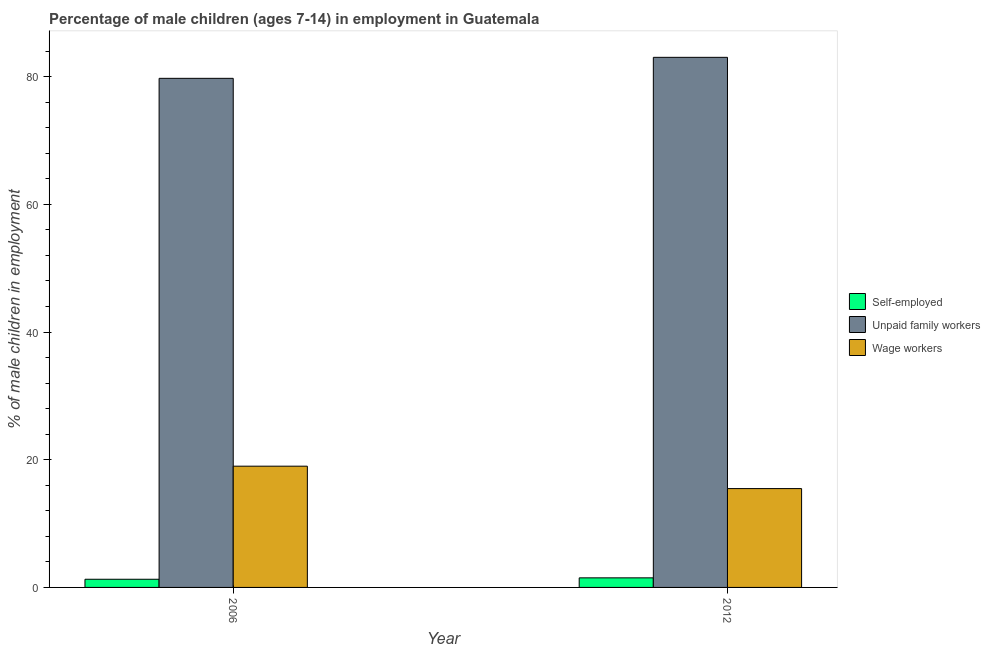How many groups of bars are there?
Ensure brevity in your answer.  2. Are the number of bars per tick equal to the number of legend labels?
Your answer should be very brief. Yes. Are the number of bars on each tick of the X-axis equal?
Offer a very short reply. Yes. What is the label of the 2nd group of bars from the left?
Ensure brevity in your answer.  2012. In how many cases, is the number of bars for a given year not equal to the number of legend labels?
Provide a short and direct response. 0. What is the percentage of children employed as unpaid family workers in 2006?
Provide a short and direct response. 79.73. Across all years, what is the maximum percentage of children employed as unpaid family workers?
Give a very brief answer. 83.02. Across all years, what is the minimum percentage of children employed as wage workers?
Your answer should be very brief. 15.48. In which year was the percentage of self employed children maximum?
Keep it short and to the point. 2012. In which year was the percentage of children employed as wage workers minimum?
Provide a succinct answer. 2012. What is the total percentage of children employed as wage workers in the graph?
Offer a terse response. 34.47. What is the difference between the percentage of children employed as wage workers in 2006 and that in 2012?
Provide a succinct answer. 3.51. What is the difference between the percentage of children employed as wage workers in 2006 and the percentage of self employed children in 2012?
Your answer should be very brief. 3.51. What is the average percentage of children employed as unpaid family workers per year?
Your response must be concise. 81.38. What is the ratio of the percentage of children employed as wage workers in 2006 to that in 2012?
Provide a succinct answer. 1.23. Is the percentage of children employed as unpaid family workers in 2006 less than that in 2012?
Make the answer very short. Yes. What does the 3rd bar from the left in 2012 represents?
Your response must be concise. Wage workers. What does the 1st bar from the right in 2006 represents?
Your answer should be compact. Wage workers. Is it the case that in every year, the sum of the percentage of self employed children and percentage of children employed as unpaid family workers is greater than the percentage of children employed as wage workers?
Your answer should be compact. Yes. How many bars are there?
Your answer should be compact. 6. What is the difference between two consecutive major ticks on the Y-axis?
Your answer should be compact. 20. Does the graph contain any zero values?
Give a very brief answer. No. Where does the legend appear in the graph?
Your answer should be very brief. Center right. How many legend labels are there?
Make the answer very short. 3. How are the legend labels stacked?
Ensure brevity in your answer.  Vertical. What is the title of the graph?
Offer a terse response. Percentage of male children (ages 7-14) in employment in Guatemala. Does "Services" appear as one of the legend labels in the graph?
Your answer should be compact. No. What is the label or title of the X-axis?
Give a very brief answer. Year. What is the label or title of the Y-axis?
Ensure brevity in your answer.  % of male children in employment. What is the % of male children in employment of Self-employed in 2006?
Ensure brevity in your answer.  1.28. What is the % of male children in employment in Unpaid family workers in 2006?
Provide a short and direct response. 79.73. What is the % of male children in employment in Wage workers in 2006?
Your answer should be compact. 18.99. What is the % of male children in employment of Self-employed in 2012?
Keep it short and to the point. 1.5. What is the % of male children in employment in Unpaid family workers in 2012?
Your response must be concise. 83.02. What is the % of male children in employment in Wage workers in 2012?
Make the answer very short. 15.48. Across all years, what is the maximum % of male children in employment in Self-employed?
Keep it short and to the point. 1.5. Across all years, what is the maximum % of male children in employment of Unpaid family workers?
Provide a succinct answer. 83.02. Across all years, what is the maximum % of male children in employment in Wage workers?
Offer a terse response. 18.99. Across all years, what is the minimum % of male children in employment in Self-employed?
Offer a terse response. 1.28. Across all years, what is the minimum % of male children in employment of Unpaid family workers?
Provide a short and direct response. 79.73. Across all years, what is the minimum % of male children in employment of Wage workers?
Give a very brief answer. 15.48. What is the total % of male children in employment in Self-employed in the graph?
Your response must be concise. 2.78. What is the total % of male children in employment of Unpaid family workers in the graph?
Ensure brevity in your answer.  162.75. What is the total % of male children in employment of Wage workers in the graph?
Your answer should be compact. 34.47. What is the difference between the % of male children in employment of Self-employed in 2006 and that in 2012?
Give a very brief answer. -0.22. What is the difference between the % of male children in employment of Unpaid family workers in 2006 and that in 2012?
Keep it short and to the point. -3.29. What is the difference between the % of male children in employment in Wage workers in 2006 and that in 2012?
Keep it short and to the point. 3.51. What is the difference between the % of male children in employment of Self-employed in 2006 and the % of male children in employment of Unpaid family workers in 2012?
Provide a short and direct response. -81.74. What is the difference between the % of male children in employment of Self-employed in 2006 and the % of male children in employment of Wage workers in 2012?
Your answer should be very brief. -14.2. What is the difference between the % of male children in employment of Unpaid family workers in 2006 and the % of male children in employment of Wage workers in 2012?
Ensure brevity in your answer.  64.25. What is the average % of male children in employment of Self-employed per year?
Provide a succinct answer. 1.39. What is the average % of male children in employment in Unpaid family workers per year?
Ensure brevity in your answer.  81.38. What is the average % of male children in employment in Wage workers per year?
Offer a very short reply. 17.23. In the year 2006, what is the difference between the % of male children in employment of Self-employed and % of male children in employment of Unpaid family workers?
Your answer should be compact. -78.45. In the year 2006, what is the difference between the % of male children in employment of Self-employed and % of male children in employment of Wage workers?
Your response must be concise. -17.71. In the year 2006, what is the difference between the % of male children in employment in Unpaid family workers and % of male children in employment in Wage workers?
Offer a terse response. 60.74. In the year 2012, what is the difference between the % of male children in employment of Self-employed and % of male children in employment of Unpaid family workers?
Provide a short and direct response. -81.52. In the year 2012, what is the difference between the % of male children in employment in Self-employed and % of male children in employment in Wage workers?
Keep it short and to the point. -13.98. In the year 2012, what is the difference between the % of male children in employment in Unpaid family workers and % of male children in employment in Wage workers?
Offer a terse response. 67.54. What is the ratio of the % of male children in employment of Self-employed in 2006 to that in 2012?
Your answer should be compact. 0.85. What is the ratio of the % of male children in employment in Unpaid family workers in 2006 to that in 2012?
Your answer should be very brief. 0.96. What is the ratio of the % of male children in employment in Wage workers in 2006 to that in 2012?
Offer a very short reply. 1.23. What is the difference between the highest and the second highest % of male children in employment of Self-employed?
Make the answer very short. 0.22. What is the difference between the highest and the second highest % of male children in employment in Unpaid family workers?
Ensure brevity in your answer.  3.29. What is the difference between the highest and the second highest % of male children in employment in Wage workers?
Give a very brief answer. 3.51. What is the difference between the highest and the lowest % of male children in employment of Self-employed?
Offer a terse response. 0.22. What is the difference between the highest and the lowest % of male children in employment of Unpaid family workers?
Offer a terse response. 3.29. What is the difference between the highest and the lowest % of male children in employment of Wage workers?
Give a very brief answer. 3.51. 